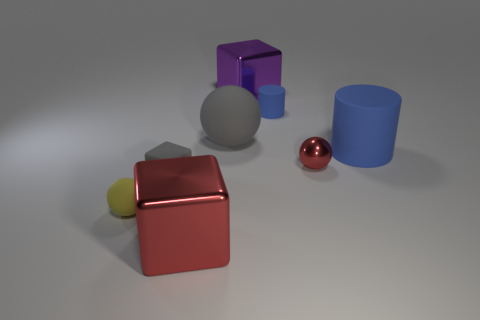What color is the small block that is the same material as the small cylinder?
Ensure brevity in your answer.  Gray. What number of tiny gray objects have the same material as the small yellow thing?
Keep it short and to the point. 1. There is a metallic sphere that is left of the big rubber cylinder; does it have the same size as the red metallic object in front of the tiny gray cube?
Offer a very short reply. No. What is the material of the block that is on the right side of the red object that is to the left of the purple object?
Provide a short and direct response. Metal. Are there fewer gray things on the right side of the big gray matte thing than large metal things in front of the yellow rubber sphere?
Your answer should be very brief. Yes. There is a thing that is the same color as the big rubber cylinder; what material is it?
Offer a very short reply. Rubber. Is there any other thing that has the same shape as the big blue rubber object?
Ensure brevity in your answer.  Yes. What is the gray object in front of the large blue cylinder made of?
Your response must be concise. Rubber. Is there any other thing that is the same size as the yellow matte thing?
Offer a very short reply. Yes. Are there any large cubes behind the purple metallic block?
Make the answer very short. No. 